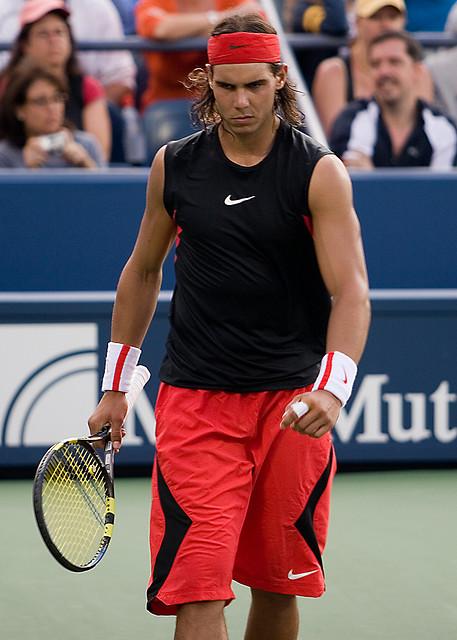What brand is the tennis player's clothes?
Give a very brief answer. Nike. Is this man happy?
Be succinct. No. Is the tennis player mad?
Answer briefly. Yes. Is this man likely right handed?
Keep it brief. Yes. 